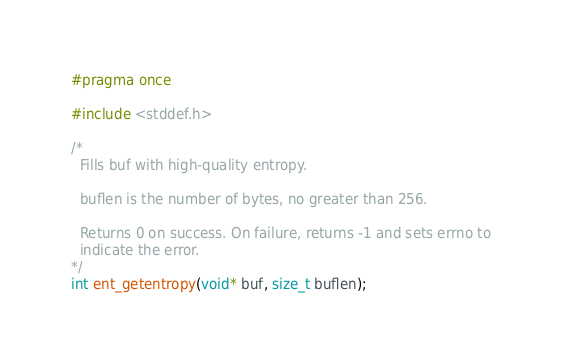Convert code to text. <code><loc_0><loc_0><loc_500><loc_500><_C_>#pragma once

#include <stddef.h>

/*
  Fills buf with high-quality entropy.

  buflen is the number of bytes, no greater than 256.

  Returns 0 on success. On failure, returns -1 and sets errno to
  indicate the error.
*/
int ent_getentropy(void* buf, size_t buflen);
</code> 